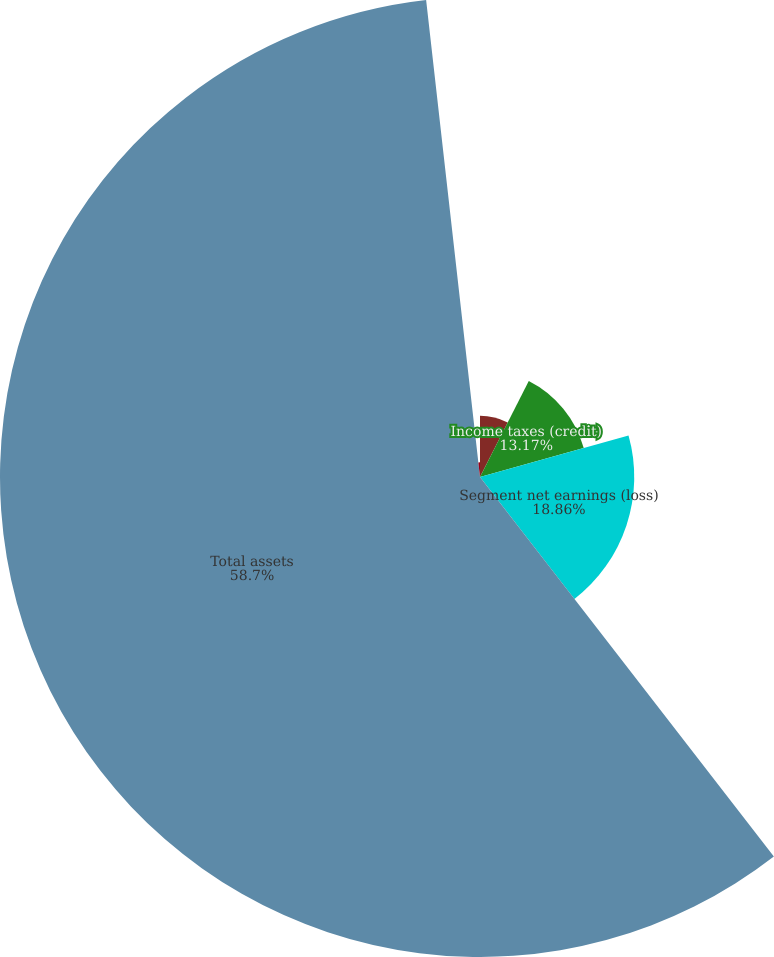Convert chart to OTSL. <chart><loc_0><loc_0><loc_500><loc_500><pie_chart><fcel>Depreciation and amortization<fcel>Income taxes (credit)<fcel>Segment net earnings (loss)<fcel>Total assets<fcel>Purchases of property plant<nl><fcel>7.48%<fcel>13.17%<fcel>18.86%<fcel>58.69%<fcel>1.79%<nl></chart> 